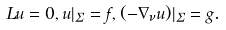<formula> <loc_0><loc_0><loc_500><loc_500>L u = 0 , u | _ { \Sigma } = f , ( - \nabla _ { \nu } u ) | _ { \Sigma } = g .</formula> 